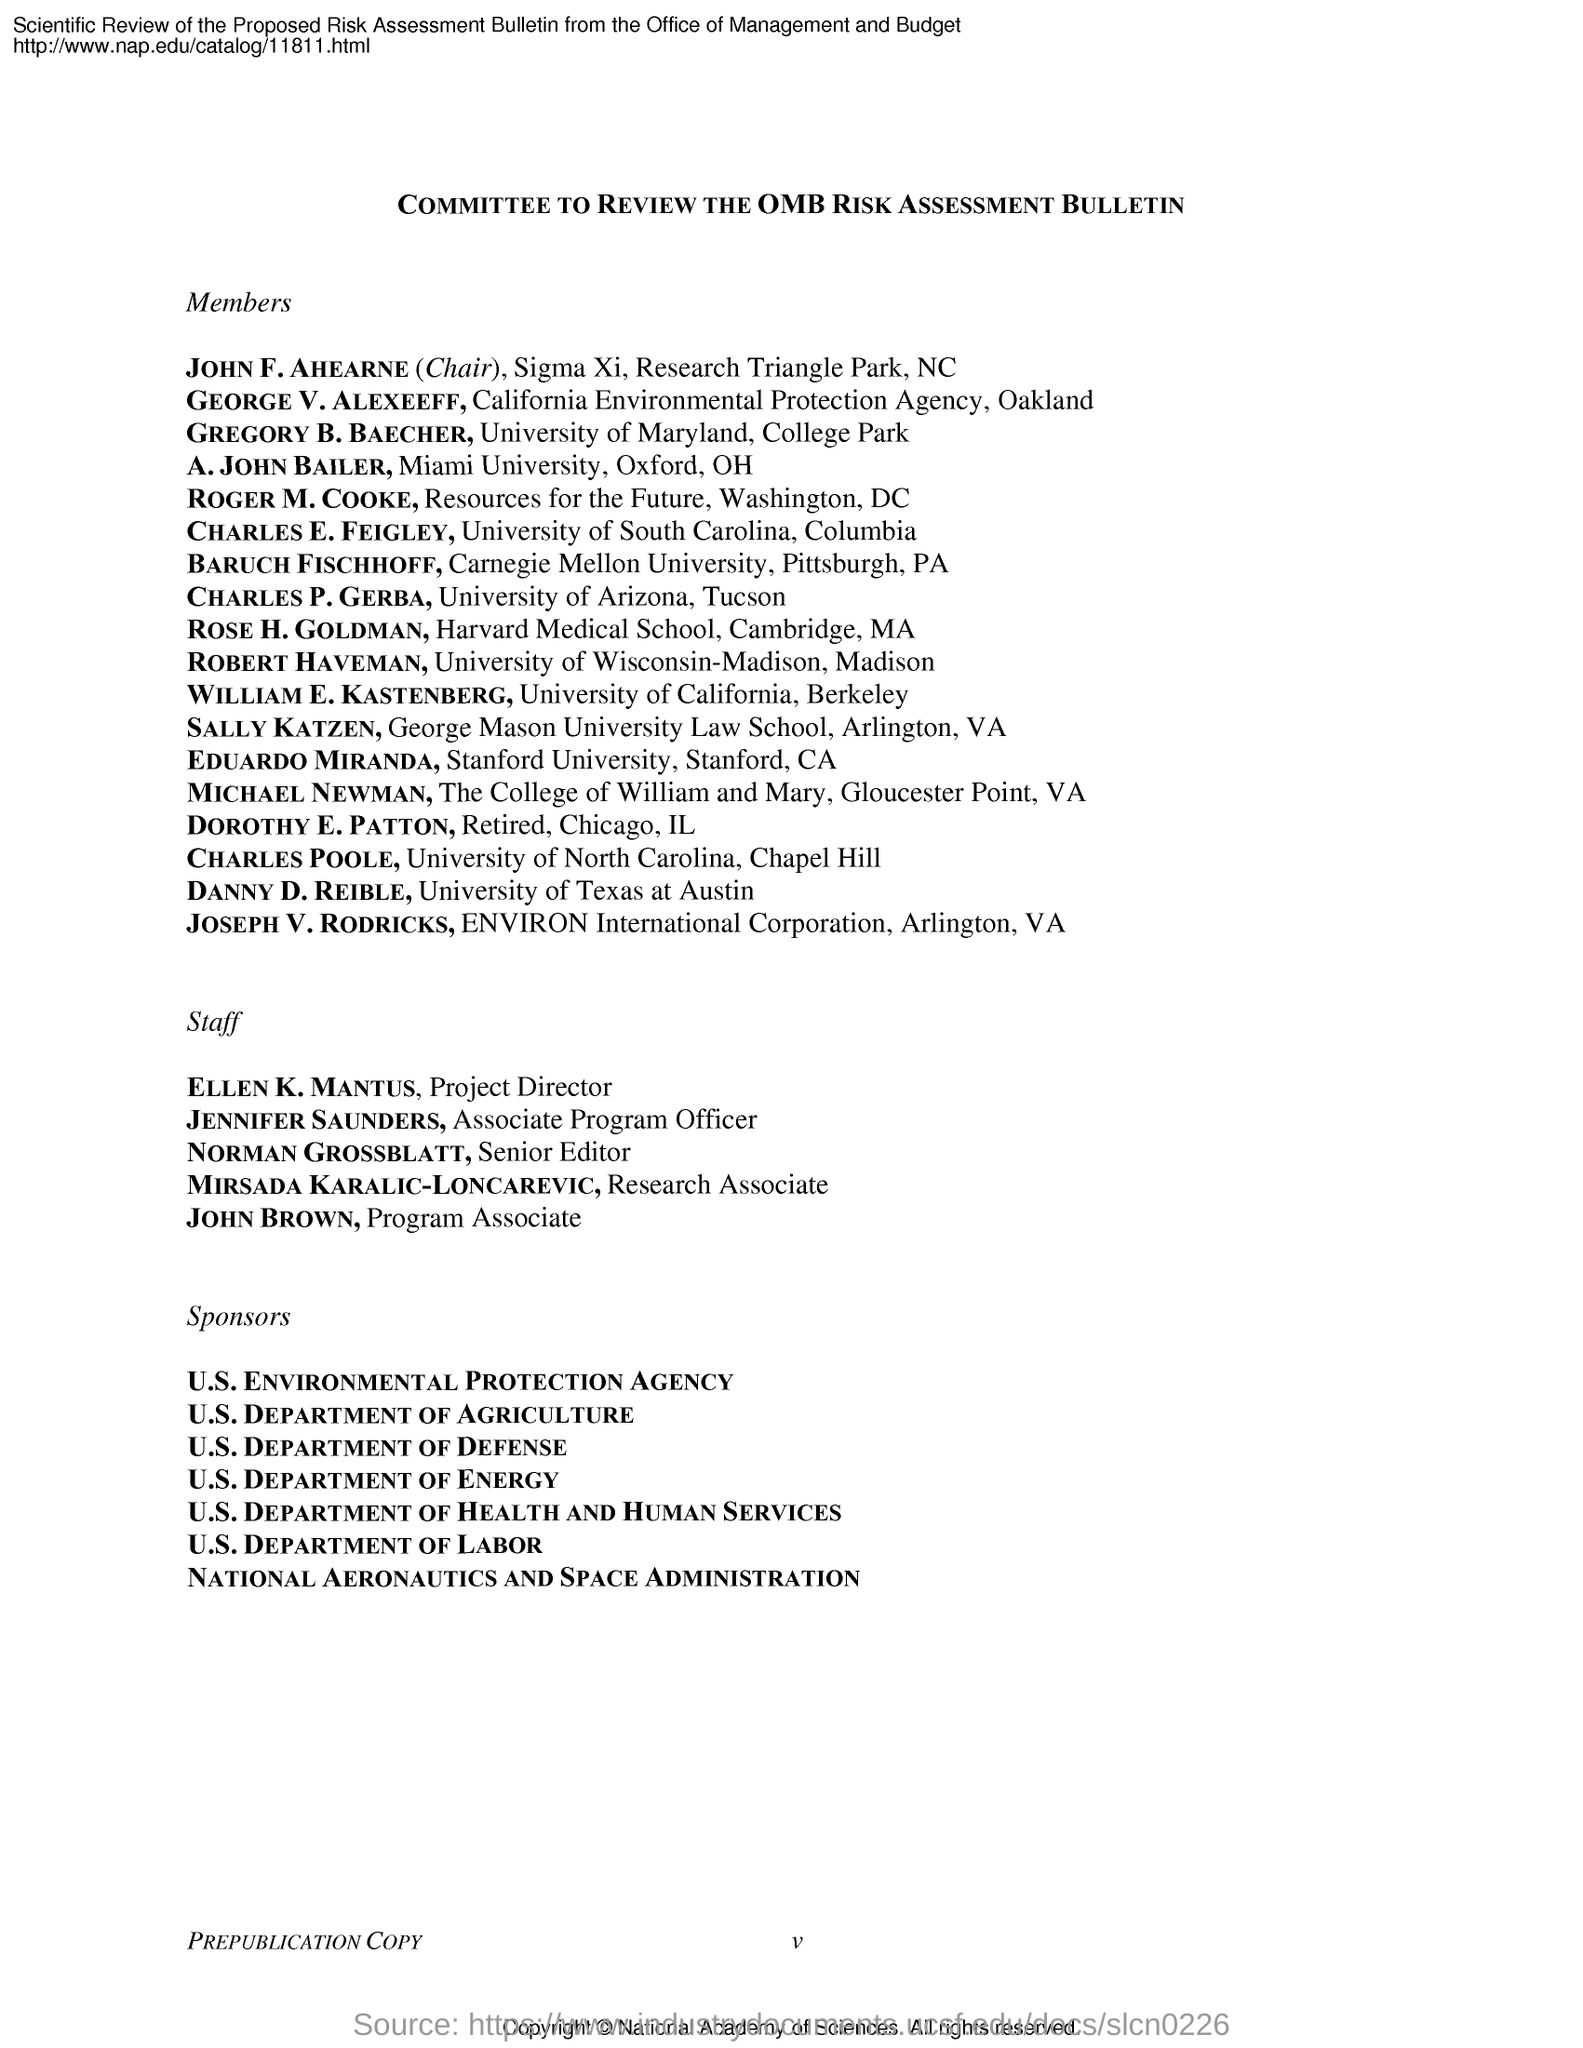Point out several critical features in this image. The project director is Ellen K. Mantus. Norman Grossblatt holds the designation of Senior Editor. The program associate is John Brown. 